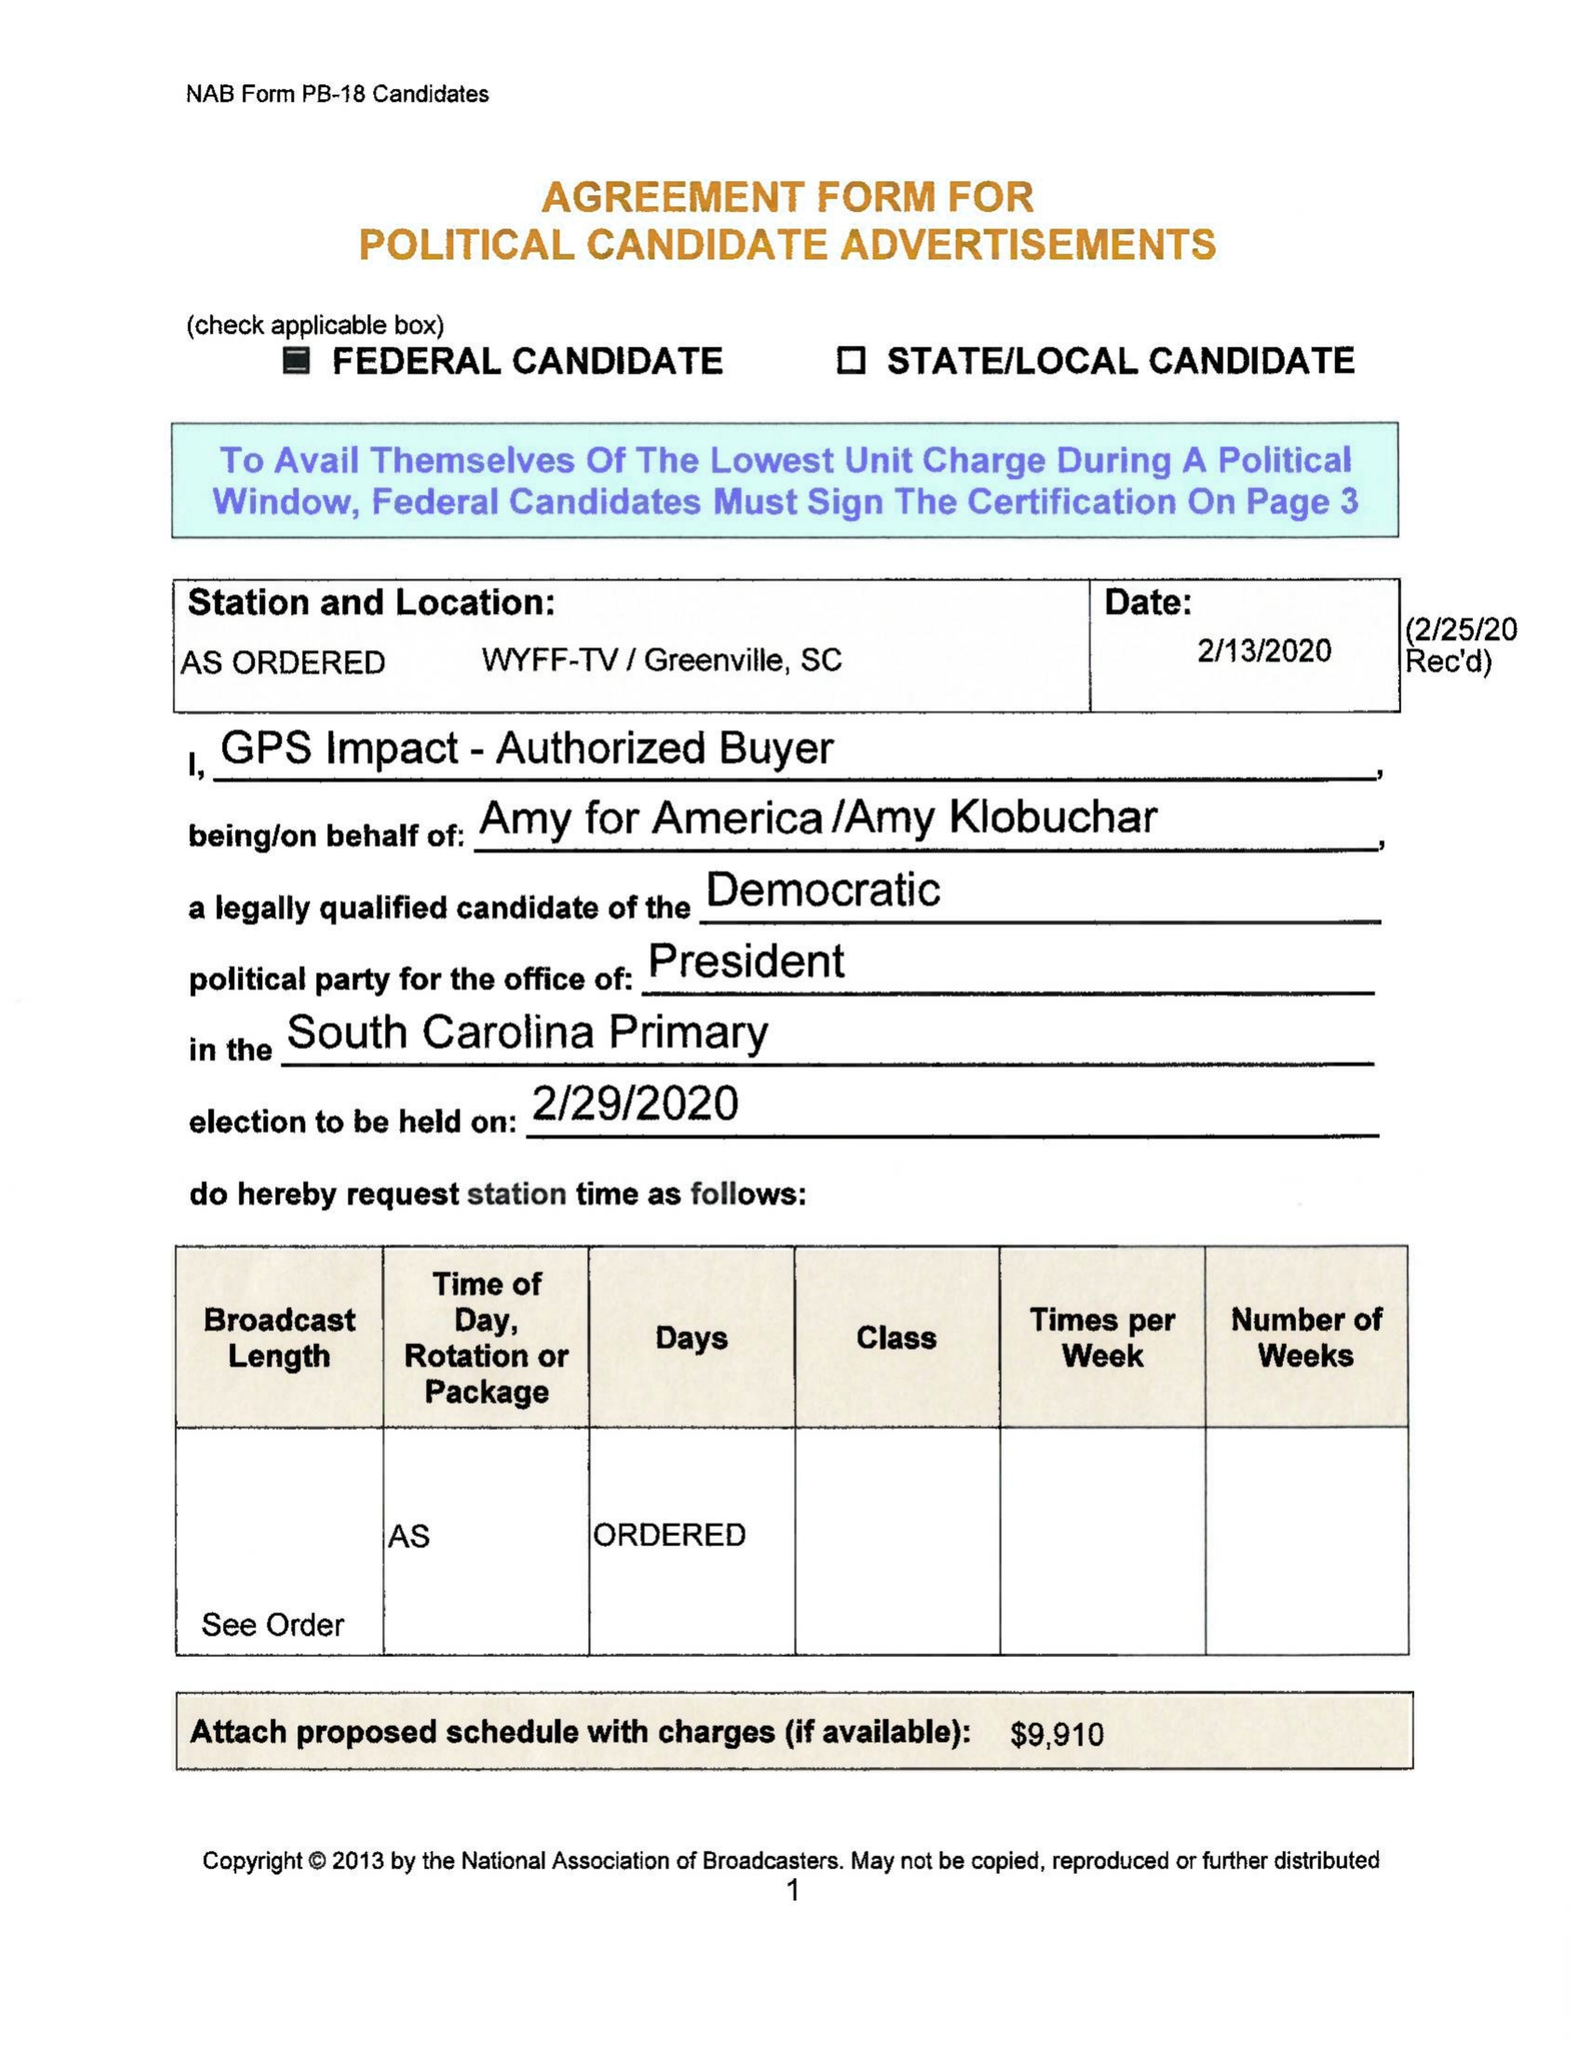What is the value for the gross_amount?
Answer the question using a single word or phrase. 9910.00 